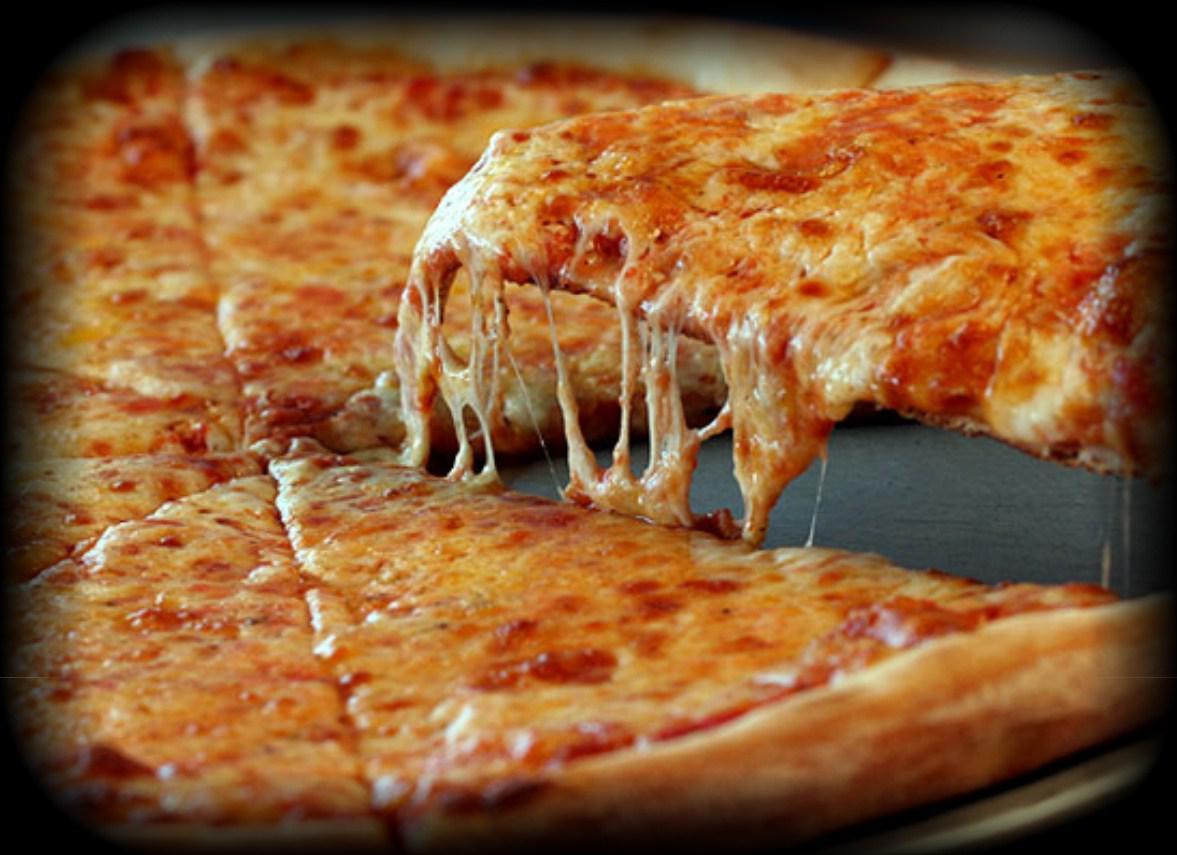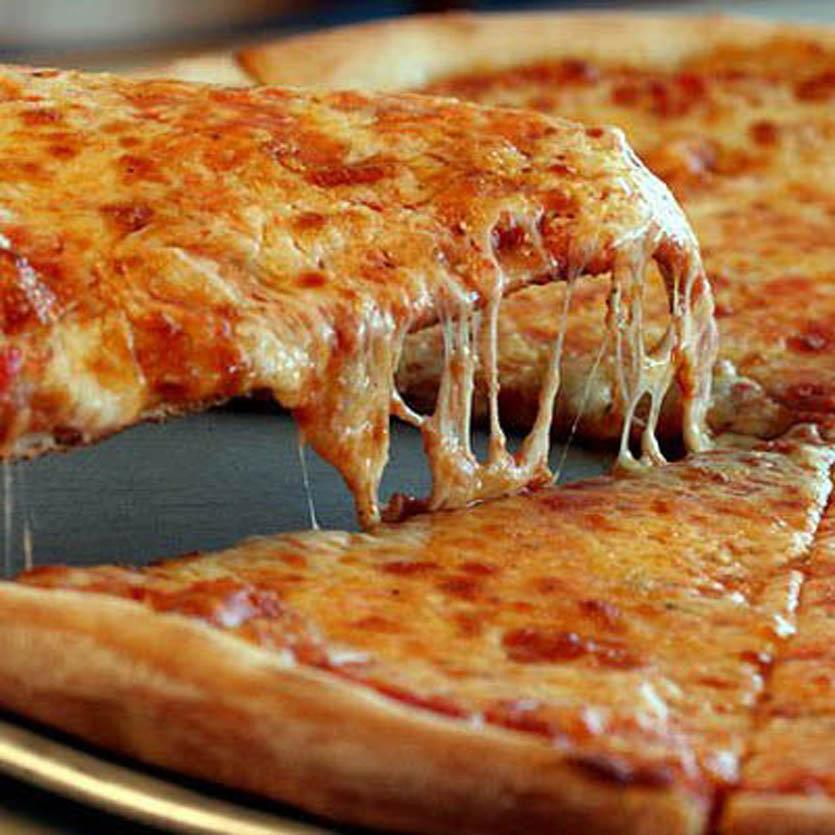The first image is the image on the left, the second image is the image on the right. Analyze the images presented: Is the assertion "There is a pizza cutter in the right image." valid? Answer yes or no. No. 